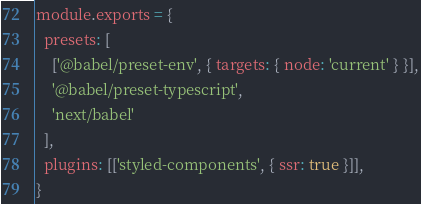<code> <loc_0><loc_0><loc_500><loc_500><_JavaScript_>module.exports = {
  presets: [
    ['@babel/preset-env', { targets: { node: 'current' } }],
    '@babel/preset-typescript',
    'next/babel'
  ],
  plugins: [['styled-components', { ssr: true }]],
}
</code> 